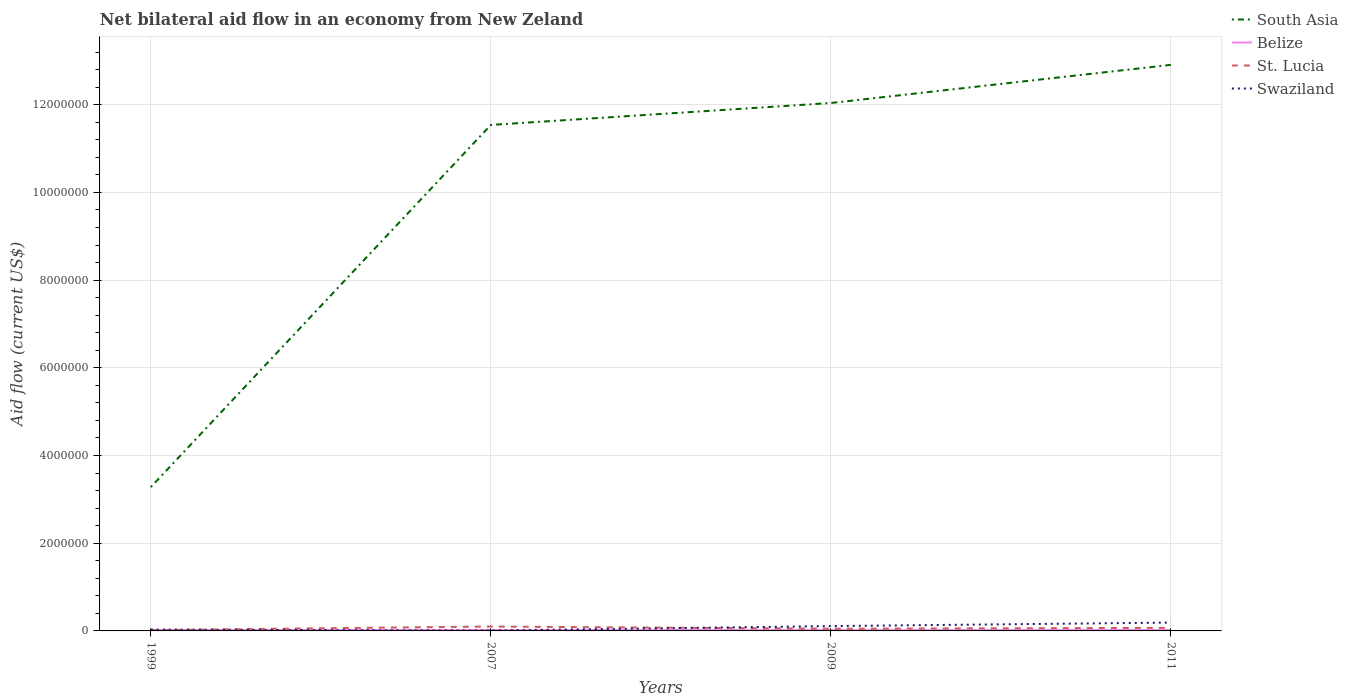Does the line corresponding to South Asia intersect with the line corresponding to St. Lucia?
Ensure brevity in your answer.  No. Across all years, what is the maximum net bilateral aid flow in South Asia?
Your response must be concise. 3.28e+06. What is the total net bilateral aid flow in Belize in the graph?
Keep it short and to the point. 0. How many lines are there?
Make the answer very short. 4. How many years are there in the graph?
Give a very brief answer. 4. Are the values on the major ticks of Y-axis written in scientific E-notation?
Offer a very short reply. No. Does the graph contain grids?
Provide a short and direct response. Yes. Where does the legend appear in the graph?
Provide a succinct answer. Top right. What is the title of the graph?
Provide a succinct answer. Net bilateral aid flow in an economy from New Zeland. Does "Denmark" appear as one of the legend labels in the graph?
Offer a terse response. No. What is the label or title of the Y-axis?
Offer a very short reply. Aid flow (current US$). What is the Aid flow (current US$) in South Asia in 1999?
Offer a terse response. 3.28e+06. What is the Aid flow (current US$) in Belize in 1999?
Ensure brevity in your answer.  2.00e+04. What is the Aid flow (current US$) in Swaziland in 1999?
Provide a succinct answer. 3.00e+04. What is the Aid flow (current US$) of South Asia in 2007?
Ensure brevity in your answer.  1.15e+07. What is the Aid flow (current US$) of Belize in 2007?
Offer a terse response. 2.00e+04. What is the Aid flow (current US$) in Swaziland in 2007?
Provide a short and direct response. 10000. What is the Aid flow (current US$) in South Asia in 2009?
Offer a terse response. 1.20e+07. What is the Aid flow (current US$) of Belize in 2009?
Keep it short and to the point. 2.00e+04. What is the Aid flow (current US$) in St. Lucia in 2009?
Provide a succinct answer. 5.00e+04. What is the Aid flow (current US$) in South Asia in 2011?
Provide a short and direct response. 1.29e+07. What is the Aid flow (current US$) of Belize in 2011?
Give a very brief answer. 2.00e+04. What is the Aid flow (current US$) in Swaziland in 2011?
Make the answer very short. 1.90e+05. Across all years, what is the maximum Aid flow (current US$) in South Asia?
Make the answer very short. 1.29e+07. Across all years, what is the maximum Aid flow (current US$) in Belize?
Your answer should be very brief. 2.00e+04. Across all years, what is the minimum Aid flow (current US$) in South Asia?
Ensure brevity in your answer.  3.28e+06. Across all years, what is the minimum Aid flow (current US$) of St. Lucia?
Keep it short and to the point. 2.00e+04. Across all years, what is the minimum Aid flow (current US$) in Swaziland?
Make the answer very short. 10000. What is the total Aid flow (current US$) in South Asia in the graph?
Provide a succinct answer. 3.98e+07. What is the total Aid flow (current US$) in St. Lucia in the graph?
Ensure brevity in your answer.  2.40e+05. What is the total Aid flow (current US$) of Swaziland in the graph?
Offer a very short reply. 3.40e+05. What is the difference between the Aid flow (current US$) of South Asia in 1999 and that in 2007?
Offer a terse response. -8.26e+06. What is the difference between the Aid flow (current US$) in South Asia in 1999 and that in 2009?
Make the answer very short. -8.76e+06. What is the difference between the Aid flow (current US$) of Belize in 1999 and that in 2009?
Provide a short and direct response. 0. What is the difference between the Aid flow (current US$) in St. Lucia in 1999 and that in 2009?
Provide a succinct answer. -3.00e+04. What is the difference between the Aid flow (current US$) of Swaziland in 1999 and that in 2009?
Offer a very short reply. -8.00e+04. What is the difference between the Aid flow (current US$) in South Asia in 1999 and that in 2011?
Your answer should be very brief. -9.63e+06. What is the difference between the Aid flow (current US$) of Belize in 1999 and that in 2011?
Provide a succinct answer. 0. What is the difference between the Aid flow (current US$) in St. Lucia in 1999 and that in 2011?
Your answer should be very brief. -5.00e+04. What is the difference between the Aid flow (current US$) in South Asia in 2007 and that in 2009?
Your answer should be very brief. -5.00e+05. What is the difference between the Aid flow (current US$) of South Asia in 2007 and that in 2011?
Your answer should be very brief. -1.37e+06. What is the difference between the Aid flow (current US$) in St. Lucia in 2007 and that in 2011?
Your answer should be very brief. 3.00e+04. What is the difference between the Aid flow (current US$) in South Asia in 2009 and that in 2011?
Offer a terse response. -8.70e+05. What is the difference between the Aid flow (current US$) of Belize in 2009 and that in 2011?
Ensure brevity in your answer.  0. What is the difference between the Aid flow (current US$) of St. Lucia in 2009 and that in 2011?
Give a very brief answer. -2.00e+04. What is the difference between the Aid flow (current US$) of Swaziland in 2009 and that in 2011?
Your answer should be compact. -8.00e+04. What is the difference between the Aid flow (current US$) of South Asia in 1999 and the Aid flow (current US$) of Belize in 2007?
Provide a succinct answer. 3.26e+06. What is the difference between the Aid flow (current US$) of South Asia in 1999 and the Aid flow (current US$) of St. Lucia in 2007?
Give a very brief answer. 3.18e+06. What is the difference between the Aid flow (current US$) of South Asia in 1999 and the Aid flow (current US$) of Swaziland in 2007?
Give a very brief answer. 3.27e+06. What is the difference between the Aid flow (current US$) in Belize in 1999 and the Aid flow (current US$) in St. Lucia in 2007?
Offer a terse response. -8.00e+04. What is the difference between the Aid flow (current US$) of St. Lucia in 1999 and the Aid flow (current US$) of Swaziland in 2007?
Your answer should be very brief. 10000. What is the difference between the Aid flow (current US$) of South Asia in 1999 and the Aid flow (current US$) of Belize in 2009?
Your answer should be very brief. 3.26e+06. What is the difference between the Aid flow (current US$) in South Asia in 1999 and the Aid flow (current US$) in St. Lucia in 2009?
Your answer should be very brief. 3.23e+06. What is the difference between the Aid flow (current US$) of South Asia in 1999 and the Aid flow (current US$) of Swaziland in 2009?
Your answer should be compact. 3.17e+06. What is the difference between the Aid flow (current US$) in South Asia in 1999 and the Aid flow (current US$) in Belize in 2011?
Your response must be concise. 3.26e+06. What is the difference between the Aid flow (current US$) of South Asia in 1999 and the Aid flow (current US$) of St. Lucia in 2011?
Keep it short and to the point. 3.21e+06. What is the difference between the Aid flow (current US$) in South Asia in 1999 and the Aid flow (current US$) in Swaziland in 2011?
Your answer should be very brief. 3.09e+06. What is the difference between the Aid flow (current US$) in South Asia in 2007 and the Aid flow (current US$) in Belize in 2009?
Offer a terse response. 1.15e+07. What is the difference between the Aid flow (current US$) in South Asia in 2007 and the Aid flow (current US$) in St. Lucia in 2009?
Ensure brevity in your answer.  1.15e+07. What is the difference between the Aid flow (current US$) of South Asia in 2007 and the Aid flow (current US$) of Swaziland in 2009?
Your response must be concise. 1.14e+07. What is the difference between the Aid flow (current US$) of South Asia in 2007 and the Aid flow (current US$) of Belize in 2011?
Your answer should be very brief. 1.15e+07. What is the difference between the Aid flow (current US$) in South Asia in 2007 and the Aid flow (current US$) in St. Lucia in 2011?
Your response must be concise. 1.15e+07. What is the difference between the Aid flow (current US$) in South Asia in 2007 and the Aid flow (current US$) in Swaziland in 2011?
Provide a succinct answer. 1.14e+07. What is the difference between the Aid flow (current US$) in Belize in 2007 and the Aid flow (current US$) in St. Lucia in 2011?
Your answer should be very brief. -5.00e+04. What is the difference between the Aid flow (current US$) of St. Lucia in 2007 and the Aid flow (current US$) of Swaziland in 2011?
Your response must be concise. -9.00e+04. What is the difference between the Aid flow (current US$) in South Asia in 2009 and the Aid flow (current US$) in Belize in 2011?
Provide a succinct answer. 1.20e+07. What is the difference between the Aid flow (current US$) of South Asia in 2009 and the Aid flow (current US$) of St. Lucia in 2011?
Your answer should be compact. 1.20e+07. What is the difference between the Aid flow (current US$) in South Asia in 2009 and the Aid flow (current US$) in Swaziland in 2011?
Your answer should be very brief. 1.18e+07. What is the difference between the Aid flow (current US$) of St. Lucia in 2009 and the Aid flow (current US$) of Swaziland in 2011?
Offer a terse response. -1.40e+05. What is the average Aid flow (current US$) of South Asia per year?
Keep it short and to the point. 9.94e+06. What is the average Aid flow (current US$) of Swaziland per year?
Give a very brief answer. 8.50e+04. In the year 1999, what is the difference between the Aid flow (current US$) of South Asia and Aid flow (current US$) of Belize?
Your answer should be very brief. 3.26e+06. In the year 1999, what is the difference between the Aid flow (current US$) in South Asia and Aid flow (current US$) in St. Lucia?
Make the answer very short. 3.26e+06. In the year 1999, what is the difference between the Aid flow (current US$) of South Asia and Aid flow (current US$) of Swaziland?
Give a very brief answer. 3.25e+06. In the year 1999, what is the difference between the Aid flow (current US$) of Belize and Aid flow (current US$) of St. Lucia?
Provide a succinct answer. 0. In the year 2007, what is the difference between the Aid flow (current US$) in South Asia and Aid flow (current US$) in Belize?
Your answer should be very brief. 1.15e+07. In the year 2007, what is the difference between the Aid flow (current US$) of South Asia and Aid flow (current US$) of St. Lucia?
Offer a very short reply. 1.14e+07. In the year 2007, what is the difference between the Aid flow (current US$) in South Asia and Aid flow (current US$) in Swaziland?
Offer a very short reply. 1.15e+07. In the year 2007, what is the difference between the Aid flow (current US$) in Belize and Aid flow (current US$) in St. Lucia?
Offer a very short reply. -8.00e+04. In the year 2007, what is the difference between the Aid flow (current US$) in Belize and Aid flow (current US$) in Swaziland?
Offer a very short reply. 10000. In the year 2007, what is the difference between the Aid flow (current US$) in St. Lucia and Aid flow (current US$) in Swaziland?
Provide a short and direct response. 9.00e+04. In the year 2009, what is the difference between the Aid flow (current US$) of South Asia and Aid flow (current US$) of Belize?
Keep it short and to the point. 1.20e+07. In the year 2009, what is the difference between the Aid flow (current US$) in South Asia and Aid flow (current US$) in St. Lucia?
Ensure brevity in your answer.  1.20e+07. In the year 2009, what is the difference between the Aid flow (current US$) of South Asia and Aid flow (current US$) of Swaziland?
Keep it short and to the point. 1.19e+07. In the year 2009, what is the difference between the Aid flow (current US$) of St. Lucia and Aid flow (current US$) of Swaziland?
Offer a very short reply. -6.00e+04. In the year 2011, what is the difference between the Aid flow (current US$) in South Asia and Aid flow (current US$) in Belize?
Your answer should be compact. 1.29e+07. In the year 2011, what is the difference between the Aid flow (current US$) of South Asia and Aid flow (current US$) of St. Lucia?
Ensure brevity in your answer.  1.28e+07. In the year 2011, what is the difference between the Aid flow (current US$) in South Asia and Aid flow (current US$) in Swaziland?
Provide a short and direct response. 1.27e+07. In the year 2011, what is the difference between the Aid flow (current US$) of Belize and Aid flow (current US$) of St. Lucia?
Keep it short and to the point. -5.00e+04. In the year 2011, what is the difference between the Aid flow (current US$) in St. Lucia and Aid flow (current US$) in Swaziland?
Your answer should be compact. -1.20e+05. What is the ratio of the Aid flow (current US$) of South Asia in 1999 to that in 2007?
Your answer should be compact. 0.28. What is the ratio of the Aid flow (current US$) in St. Lucia in 1999 to that in 2007?
Keep it short and to the point. 0.2. What is the ratio of the Aid flow (current US$) of South Asia in 1999 to that in 2009?
Keep it short and to the point. 0.27. What is the ratio of the Aid flow (current US$) in St. Lucia in 1999 to that in 2009?
Your answer should be very brief. 0.4. What is the ratio of the Aid flow (current US$) in Swaziland in 1999 to that in 2009?
Provide a succinct answer. 0.27. What is the ratio of the Aid flow (current US$) of South Asia in 1999 to that in 2011?
Give a very brief answer. 0.25. What is the ratio of the Aid flow (current US$) of Belize in 1999 to that in 2011?
Keep it short and to the point. 1. What is the ratio of the Aid flow (current US$) in St. Lucia in 1999 to that in 2011?
Offer a very short reply. 0.29. What is the ratio of the Aid flow (current US$) in Swaziland in 1999 to that in 2011?
Make the answer very short. 0.16. What is the ratio of the Aid flow (current US$) in South Asia in 2007 to that in 2009?
Provide a short and direct response. 0.96. What is the ratio of the Aid flow (current US$) in Belize in 2007 to that in 2009?
Provide a short and direct response. 1. What is the ratio of the Aid flow (current US$) of Swaziland in 2007 to that in 2009?
Offer a terse response. 0.09. What is the ratio of the Aid flow (current US$) in South Asia in 2007 to that in 2011?
Keep it short and to the point. 0.89. What is the ratio of the Aid flow (current US$) of St. Lucia in 2007 to that in 2011?
Your answer should be very brief. 1.43. What is the ratio of the Aid flow (current US$) of Swaziland in 2007 to that in 2011?
Ensure brevity in your answer.  0.05. What is the ratio of the Aid flow (current US$) of South Asia in 2009 to that in 2011?
Your answer should be very brief. 0.93. What is the ratio of the Aid flow (current US$) in Swaziland in 2009 to that in 2011?
Make the answer very short. 0.58. What is the difference between the highest and the second highest Aid flow (current US$) in South Asia?
Provide a succinct answer. 8.70e+05. What is the difference between the highest and the second highest Aid flow (current US$) of Belize?
Your response must be concise. 0. What is the difference between the highest and the second highest Aid flow (current US$) of St. Lucia?
Provide a short and direct response. 3.00e+04. What is the difference between the highest and the second highest Aid flow (current US$) in Swaziland?
Ensure brevity in your answer.  8.00e+04. What is the difference between the highest and the lowest Aid flow (current US$) in South Asia?
Keep it short and to the point. 9.63e+06. What is the difference between the highest and the lowest Aid flow (current US$) in Belize?
Offer a very short reply. 0. What is the difference between the highest and the lowest Aid flow (current US$) in St. Lucia?
Give a very brief answer. 8.00e+04. What is the difference between the highest and the lowest Aid flow (current US$) in Swaziland?
Offer a very short reply. 1.80e+05. 